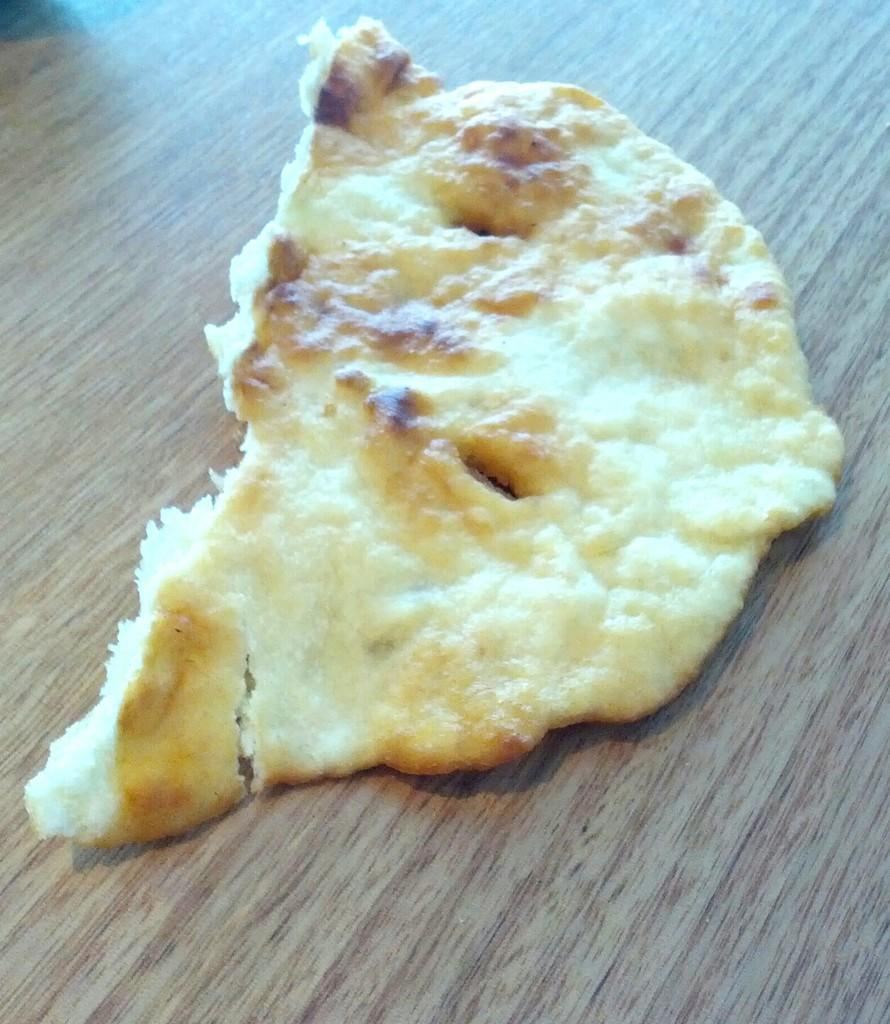What is the main subject of the image? There is a food item in the image. Can you describe the surface on which the food item is placed? The food item is placed on a wooden surface. How many screws can be seen holding the stem of the light fixture in the image? There is no light fixture or screws present in the image; it only features a food item placed on a wooden surface. 